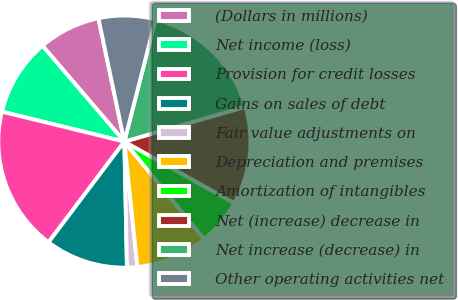Convert chart to OTSL. <chart><loc_0><loc_0><loc_500><loc_500><pie_chart><fcel>(Dollars in millions)<fcel>Net income (loss)<fcel>Provision for credit losses<fcel>Gains on sales of debt<fcel>Fair value adjustments on<fcel>Depreciation and premises<fcel>Amortization of intangibles<fcel>Net (increase) decrease in<fcel>Net increase (decrease) in<fcel>Other operating activities net<nl><fcel>7.95%<fcel>9.93%<fcel>18.54%<fcel>10.6%<fcel>1.32%<fcel>9.27%<fcel>5.96%<fcel>12.58%<fcel>16.56%<fcel>7.28%<nl></chart> 